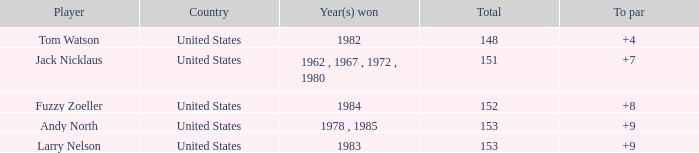What is the Total of the Player with a Year(s) won of 1982? 148.0. 